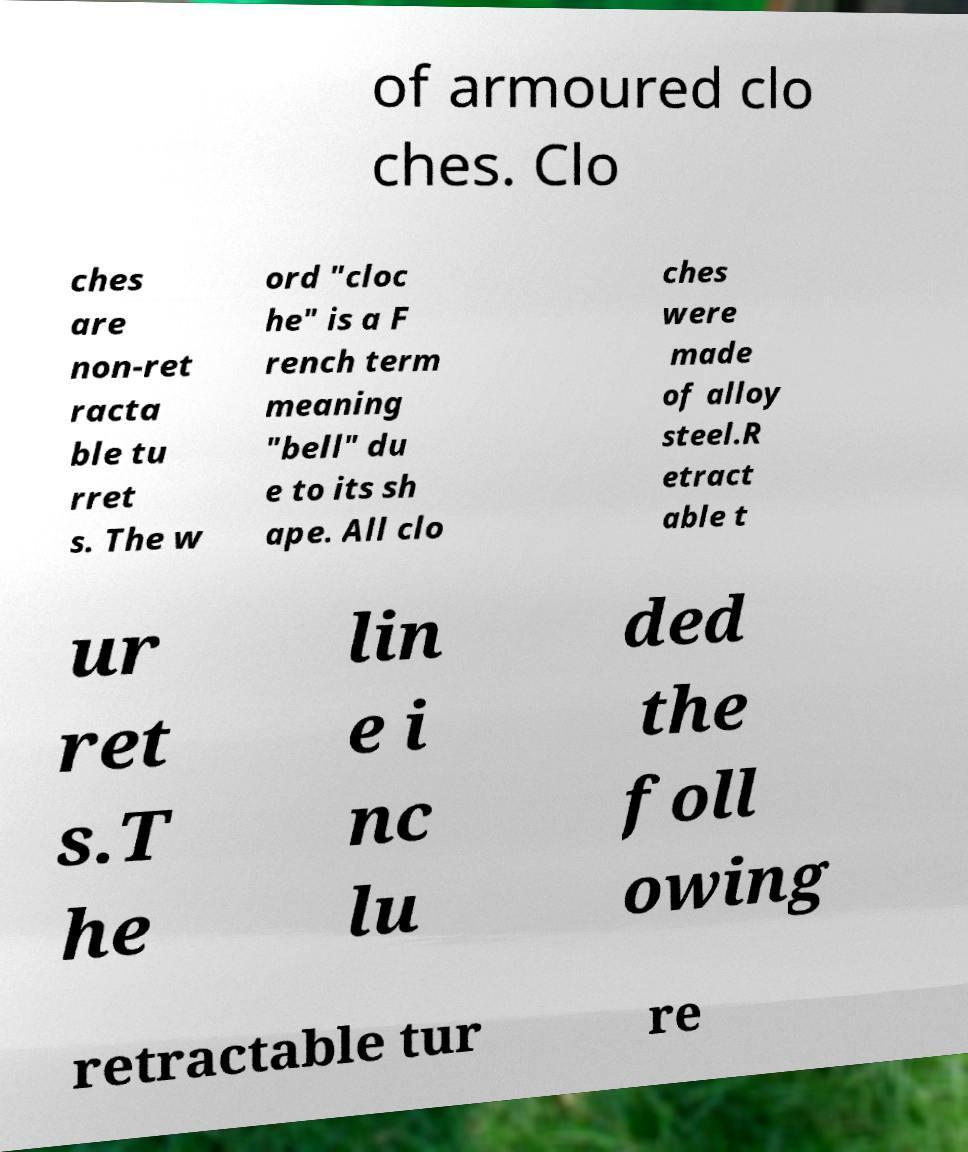Can you accurately transcribe the text from the provided image for me? of armoured clo ches. Clo ches are non-ret racta ble tu rret s. The w ord "cloc he" is a F rench term meaning "bell" du e to its sh ape. All clo ches were made of alloy steel.R etract able t ur ret s.T he lin e i nc lu ded the foll owing retractable tur re 